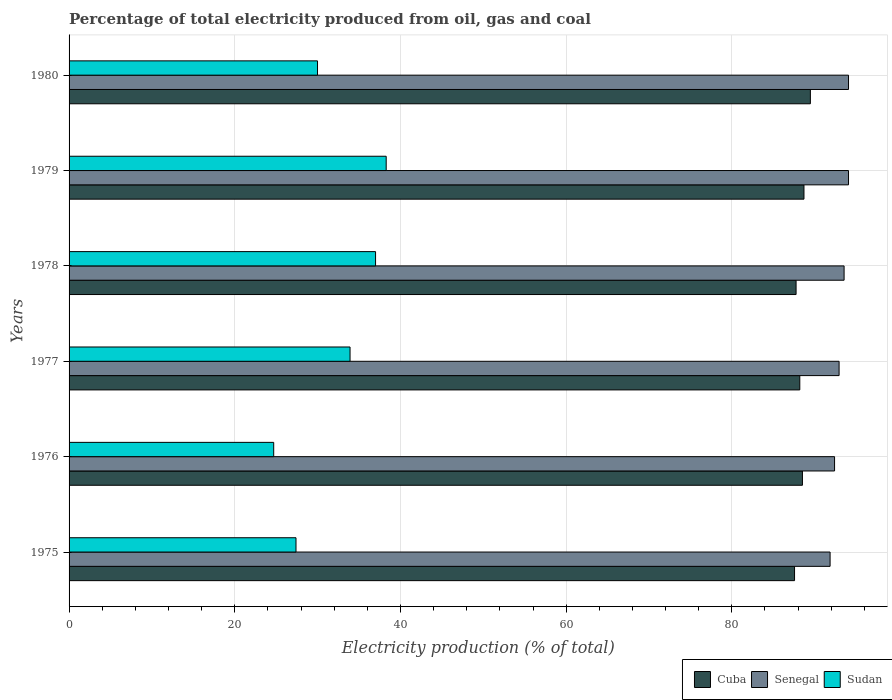How many different coloured bars are there?
Offer a very short reply. 3. Are the number of bars per tick equal to the number of legend labels?
Keep it short and to the point. Yes. How many bars are there on the 1st tick from the top?
Make the answer very short. 3. How many bars are there on the 3rd tick from the bottom?
Give a very brief answer. 3. What is the label of the 4th group of bars from the top?
Provide a short and direct response. 1977. What is the electricity production in in Sudan in 1977?
Offer a terse response. 33.92. Across all years, what is the maximum electricity production in in Senegal?
Keep it short and to the point. 94.08. Across all years, what is the minimum electricity production in in Cuba?
Ensure brevity in your answer.  87.57. In which year was the electricity production in in Cuba maximum?
Make the answer very short. 1980. In which year was the electricity production in in Sudan minimum?
Give a very brief answer. 1976. What is the total electricity production in in Cuba in the graph?
Give a very brief answer. 530.23. What is the difference between the electricity production in in Cuba in 1975 and that in 1980?
Your answer should be very brief. -1.91. What is the difference between the electricity production in in Senegal in 1980 and the electricity production in in Cuba in 1975?
Your answer should be very brief. 6.51. What is the average electricity production in in Cuba per year?
Ensure brevity in your answer.  88.37. In the year 1976, what is the difference between the electricity production in in Cuba and electricity production in in Senegal?
Your answer should be compact. -3.88. In how many years, is the electricity production in in Senegal greater than 8 %?
Your answer should be very brief. 6. What is the ratio of the electricity production in in Senegal in 1976 to that in 1979?
Offer a terse response. 0.98. Is the difference between the electricity production in in Cuba in 1976 and 1979 greater than the difference between the electricity production in in Senegal in 1976 and 1979?
Offer a very short reply. Yes. What is the difference between the highest and the second highest electricity production in in Sudan?
Your answer should be very brief. 1.28. What is the difference between the highest and the lowest electricity production in in Sudan?
Offer a terse response. 13.58. In how many years, is the electricity production in in Senegal greater than the average electricity production in in Senegal taken over all years?
Your answer should be very brief. 3. Is the sum of the electricity production in in Senegal in 1978 and 1979 greater than the maximum electricity production in in Cuba across all years?
Your response must be concise. Yes. What does the 2nd bar from the top in 1980 represents?
Your answer should be compact. Senegal. What does the 1st bar from the bottom in 1980 represents?
Provide a succinct answer. Cuba. Is it the case that in every year, the sum of the electricity production in in Cuba and electricity production in in Senegal is greater than the electricity production in in Sudan?
Your answer should be compact. Yes. How many bars are there?
Your answer should be very brief. 18. How many years are there in the graph?
Give a very brief answer. 6. What is the difference between two consecutive major ticks on the X-axis?
Offer a very short reply. 20. Are the values on the major ticks of X-axis written in scientific E-notation?
Your answer should be very brief. No. Does the graph contain any zero values?
Offer a terse response. No. How many legend labels are there?
Your answer should be compact. 3. How are the legend labels stacked?
Your answer should be compact. Horizontal. What is the title of the graph?
Provide a short and direct response. Percentage of total electricity produced from oil, gas and coal. Does "Qatar" appear as one of the legend labels in the graph?
Ensure brevity in your answer.  No. What is the label or title of the X-axis?
Your answer should be compact. Electricity production (% of total). What is the label or title of the Y-axis?
Your answer should be compact. Years. What is the Electricity production (% of total) of Cuba in 1975?
Provide a succinct answer. 87.57. What is the Electricity production (% of total) of Senegal in 1975?
Offer a very short reply. 91.86. What is the Electricity production (% of total) in Sudan in 1975?
Your answer should be compact. 27.39. What is the Electricity production (% of total) of Cuba in 1976?
Provide a succinct answer. 88.52. What is the Electricity production (% of total) of Senegal in 1976?
Keep it short and to the point. 92.4. What is the Electricity production (% of total) of Sudan in 1976?
Your response must be concise. 24.7. What is the Electricity production (% of total) in Cuba in 1977?
Offer a terse response. 88.2. What is the Electricity production (% of total) in Senegal in 1977?
Give a very brief answer. 92.95. What is the Electricity production (% of total) in Sudan in 1977?
Keep it short and to the point. 33.92. What is the Electricity production (% of total) in Cuba in 1978?
Offer a very short reply. 87.75. What is the Electricity production (% of total) of Senegal in 1978?
Give a very brief answer. 93.55. What is the Electricity production (% of total) in Sudan in 1978?
Provide a succinct answer. 36.99. What is the Electricity production (% of total) in Cuba in 1979?
Give a very brief answer. 88.7. What is the Electricity production (% of total) in Senegal in 1979?
Make the answer very short. 94.08. What is the Electricity production (% of total) in Sudan in 1979?
Provide a short and direct response. 38.28. What is the Electricity production (% of total) in Cuba in 1980?
Keep it short and to the point. 89.48. What is the Electricity production (% of total) in Senegal in 1980?
Give a very brief answer. 94.08. What is the Electricity production (% of total) of Sudan in 1980?
Your response must be concise. 29.99. Across all years, what is the maximum Electricity production (% of total) in Cuba?
Give a very brief answer. 89.48. Across all years, what is the maximum Electricity production (% of total) of Senegal?
Ensure brevity in your answer.  94.08. Across all years, what is the maximum Electricity production (% of total) in Sudan?
Provide a succinct answer. 38.28. Across all years, what is the minimum Electricity production (% of total) in Cuba?
Your answer should be compact. 87.57. Across all years, what is the minimum Electricity production (% of total) in Senegal?
Your answer should be compact. 91.86. Across all years, what is the minimum Electricity production (% of total) of Sudan?
Provide a succinct answer. 24.7. What is the total Electricity production (% of total) of Cuba in the graph?
Ensure brevity in your answer.  530.23. What is the total Electricity production (% of total) in Senegal in the graph?
Ensure brevity in your answer.  558.92. What is the total Electricity production (% of total) of Sudan in the graph?
Provide a short and direct response. 191.27. What is the difference between the Electricity production (% of total) in Cuba in 1975 and that in 1976?
Your response must be concise. -0.95. What is the difference between the Electricity production (% of total) of Senegal in 1975 and that in 1976?
Your answer should be very brief. -0.54. What is the difference between the Electricity production (% of total) of Sudan in 1975 and that in 1976?
Keep it short and to the point. 2.69. What is the difference between the Electricity production (% of total) in Cuba in 1975 and that in 1977?
Your response must be concise. -0.63. What is the difference between the Electricity production (% of total) in Senegal in 1975 and that in 1977?
Provide a short and direct response. -1.09. What is the difference between the Electricity production (% of total) of Sudan in 1975 and that in 1977?
Keep it short and to the point. -6.52. What is the difference between the Electricity production (% of total) in Cuba in 1975 and that in 1978?
Offer a very short reply. -0.19. What is the difference between the Electricity production (% of total) of Senegal in 1975 and that in 1978?
Offer a very short reply. -1.69. What is the difference between the Electricity production (% of total) of Sudan in 1975 and that in 1978?
Offer a very short reply. -9.6. What is the difference between the Electricity production (% of total) in Cuba in 1975 and that in 1979?
Offer a very short reply. -1.14. What is the difference between the Electricity production (% of total) in Senegal in 1975 and that in 1979?
Provide a succinct answer. -2.22. What is the difference between the Electricity production (% of total) of Sudan in 1975 and that in 1979?
Offer a very short reply. -10.89. What is the difference between the Electricity production (% of total) of Cuba in 1975 and that in 1980?
Your answer should be very brief. -1.91. What is the difference between the Electricity production (% of total) in Senegal in 1975 and that in 1980?
Your response must be concise. -2.22. What is the difference between the Electricity production (% of total) in Sudan in 1975 and that in 1980?
Make the answer very short. -2.6. What is the difference between the Electricity production (% of total) of Cuba in 1976 and that in 1977?
Your response must be concise. 0.32. What is the difference between the Electricity production (% of total) in Senegal in 1976 and that in 1977?
Give a very brief answer. -0.55. What is the difference between the Electricity production (% of total) of Sudan in 1976 and that in 1977?
Offer a terse response. -9.22. What is the difference between the Electricity production (% of total) of Cuba in 1976 and that in 1978?
Your response must be concise. 0.77. What is the difference between the Electricity production (% of total) of Senegal in 1976 and that in 1978?
Offer a very short reply. -1.15. What is the difference between the Electricity production (% of total) of Sudan in 1976 and that in 1978?
Offer a very short reply. -12.29. What is the difference between the Electricity production (% of total) of Cuba in 1976 and that in 1979?
Your answer should be very brief. -0.18. What is the difference between the Electricity production (% of total) of Senegal in 1976 and that in 1979?
Provide a short and direct response. -1.69. What is the difference between the Electricity production (% of total) of Sudan in 1976 and that in 1979?
Offer a terse response. -13.58. What is the difference between the Electricity production (% of total) in Cuba in 1976 and that in 1980?
Keep it short and to the point. -0.96. What is the difference between the Electricity production (% of total) of Senegal in 1976 and that in 1980?
Provide a succinct answer. -1.69. What is the difference between the Electricity production (% of total) of Sudan in 1976 and that in 1980?
Offer a very short reply. -5.29. What is the difference between the Electricity production (% of total) of Cuba in 1977 and that in 1978?
Ensure brevity in your answer.  0.45. What is the difference between the Electricity production (% of total) in Senegal in 1977 and that in 1978?
Ensure brevity in your answer.  -0.6. What is the difference between the Electricity production (% of total) of Sudan in 1977 and that in 1978?
Provide a succinct answer. -3.08. What is the difference between the Electricity production (% of total) in Cuba in 1977 and that in 1979?
Your answer should be very brief. -0.5. What is the difference between the Electricity production (% of total) in Senegal in 1977 and that in 1979?
Keep it short and to the point. -1.14. What is the difference between the Electricity production (% of total) of Sudan in 1977 and that in 1979?
Ensure brevity in your answer.  -4.36. What is the difference between the Electricity production (% of total) of Cuba in 1977 and that in 1980?
Provide a short and direct response. -1.28. What is the difference between the Electricity production (% of total) in Senegal in 1977 and that in 1980?
Your answer should be compact. -1.14. What is the difference between the Electricity production (% of total) in Sudan in 1977 and that in 1980?
Your answer should be compact. 3.93. What is the difference between the Electricity production (% of total) in Cuba in 1978 and that in 1979?
Make the answer very short. -0.95. What is the difference between the Electricity production (% of total) in Senegal in 1978 and that in 1979?
Your answer should be compact. -0.53. What is the difference between the Electricity production (% of total) in Sudan in 1978 and that in 1979?
Give a very brief answer. -1.28. What is the difference between the Electricity production (% of total) of Cuba in 1978 and that in 1980?
Offer a terse response. -1.73. What is the difference between the Electricity production (% of total) in Senegal in 1978 and that in 1980?
Your response must be concise. -0.53. What is the difference between the Electricity production (% of total) in Sudan in 1978 and that in 1980?
Provide a short and direct response. 7.01. What is the difference between the Electricity production (% of total) in Cuba in 1979 and that in 1980?
Make the answer very short. -0.77. What is the difference between the Electricity production (% of total) in Senegal in 1979 and that in 1980?
Keep it short and to the point. 0. What is the difference between the Electricity production (% of total) of Sudan in 1979 and that in 1980?
Ensure brevity in your answer.  8.29. What is the difference between the Electricity production (% of total) of Cuba in 1975 and the Electricity production (% of total) of Senegal in 1976?
Offer a very short reply. -4.83. What is the difference between the Electricity production (% of total) of Cuba in 1975 and the Electricity production (% of total) of Sudan in 1976?
Provide a succinct answer. 62.87. What is the difference between the Electricity production (% of total) in Senegal in 1975 and the Electricity production (% of total) in Sudan in 1976?
Ensure brevity in your answer.  67.16. What is the difference between the Electricity production (% of total) in Cuba in 1975 and the Electricity production (% of total) in Senegal in 1977?
Provide a succinct answer. -5.38. What is the difference between the Electricity production (% of total) of Cuba in 1975 and the Electricity production (% of total) of Sudan in 1977?
Keep it short and to the point. 53.65. What is the difference between the Electricity production (% of total) in Senegal in 1975 and the Electricity production (% of total) in Sudan in 1977?
Give a very brief answer. 57.94. What is the difference between the Electricity production (% of total) in Cuba in 1975 and the Electricity production (% of total) in Senegal in 1978?
Provide a succinct answer. -5.98. What is the difference between the Electricity production (% of total) in Cuba in 1975 and the Electricity production (% of total) in Sudan in 1978?
Make the answer very short. 50.57. What is the difference between the Electricity production (% of total) in Senegal in 1975 and the Electricity production (% of total) in Sudan in 1978?
Offer a very short reply. 54.86. What is the difference between the Electricity production (% of total) in Cuba in 1975 and the Electricity production (% of total) in Senegal in 1979?
Provide a short and direct response. -6.51. What is the difference between the Electricity production (% of total) of Cuba in 1975 and the Electricity production (% of total) of Sudan in 1979?
Make the answer very short. 49.29. What is the difference between the Electricity production (% of total) in Senegal in 1975 and the Electricity production (% of total) in Sudan in 1979?
Ensure brevity in your answer.  53.58. What is the difference between the Electricity production (% of total) in Cuba in 1975 and the Electricity production (% of total) in Senegal in 1980?
Ensure brevity in your answer.  -6.51. What is the difference between the Electricity production (% of total) in Cuba in 1975 and the Electricity production (% of total) in Sudan in 1980?
Offer a very short reply. 57.58. What is the difference between the Electricity production (% of total) of Senegal in 1975 and the Electricity production (% of total) of Sudan in 1980?
Make the answer very short. 61.87. What is the difference between the Electricity production (% of total) in Cuba in 1976 and the Electricity production (% of total) in Senegal in 1977?
Ensure brevity in your answer.  -4.43. What is the difference between the Electricity production (% of total) in Cuba in 1976 and the Electricity production (% of total) in Sudan in 1977?
Ensure brevity in your answer.  54.6. What is the difference between the Electricity production (% of total) of Senegal in 1976 and the Electricity production (% of total) of Sudan in 1977?
Provide a succinct answer. 58.48. What is the difference between the Electricity production (% of total) of Cuba in 1976 and the Electricity production (% of total) of Senegal in 1978?
Offer a very short reply. -5.03. What is the difference between the Electricity production (% of total) in Cuba in 1976 and the Electricity production (% of total) in Sudan in 1978?
Ensure brevity in your answer.  51.53. What is the difference between the Electricity production (% of total) of Senegal in 1976 and the Electricity production (% of total) of Sudan in 1978?
Offer a terse response. 55.4. What is the difference between the Electricity production (% of total) in Cuba in 1976 and the Electricity production (% of total) in Senegal in 1979?
Your answer should be very brief. -5.56. What is the difference between the Electricity production (% of total) in Cuba in 1976 and the Electricity production (% of total) in Sudan in 1979?
Make the answer very short. 50.24. What is the difference between the Electricity production (% of total) in Senegal in 1976 and the Electricity production (% of total) in Sudan in 1979?
Ensure brevity in your answer.  54.12. What is the difference between the Electricity production (% of total) of Cuba in 1976 and the Electricity production (% of total) of Senegal in 1980?
Provide a succinct answer. -5.56. What is the difference between the Electricity production (% of total) of Cuba in 1976 and the Electricity production (% of total) of Sudan in 1980?
Your answer should be very brief. 58.53. What is the difference between the Electricity production (% of total) of Senegal in 1976 and the Electricity production (% of total) of Sudan in 1980?
Give a very brief answer. 62.41. What is the difference between the Electricity production (% of total) in Cuba in 1977 and the Electricity production (% of total) in Senegal in 1978?
Make the answer very short. -5.35. What is the difference between the Electricity production (% of total) in Cuba in 1977 and the Electricity production (% of total) in Sudan in 1978?
Ensure brevity in your answer.  51.21. What is the difference between the Electricity production (% of total) in Senegal in 1977 and the Electricity production (% of total) in Sudan in 1978?
Your response must be concise. 55.95. What is the difference between the Electricity production (% of total) in Cuba in 1977 and the Electricity production (% of total) in Senegal in 1979?
Keep it short and to the point. -5.88. What is the difference between the Electricity production (% of total) in Cuba in 1977 and the Electricity production (% of total) in Sudan in 1979?
Ensure brevity in your answer.  49.92. What is the difference between the Electricity production (% of total) in Senegal in 1977 and the Electricity production (% of total) in Sudan in 1979?
Give a very brief answer. 54.67. What is the difference between the Electricity production (% of total) in Cuba in 1977 and the Electricity production (% of total) in Senegal in 1980?
Your answer should be compact. -5.88. What is the difference between the Electricity production (% of total) in Cuba in 1977 and the Electricity production (% of total) in Sudan in 1980?
Give a very brief answer. 58.21. What is the difference between the Electricity production (% of total) of Senegal in 1977 and the Electricity production (% of total) of Sudan in 1980?
Provide a short and direct response. 62.96. What is the difference between the Electricity production (% of total) in Cuba in 1978 and the Electricity production (% of total) in Senegal in 1979?
Your response must be concise. -6.33. What is the difference between the Electricity production (% of total) in Cuba in 1978 and the Electricity production (% of total) in Sudan in 1979?
Provide a succinct answer. 49.48. What is the difference between the Electricity production (% of total) in Senegal in 1978 and the Electricity production (% of total) in Sudan in 1979?
Provide a short and direct response. 55.27. What is the difference between the Electricity production (% of total) of Cuba in 1978 and the Electricity production (% of total) of Senegal in 1980?
Provide a short and direct response. -6.33. What is the difference between the Electricity production (% of total) of Cuba in 1978 and the Electricity production (% of total) of Sudan in 1980?
Provide a succinct answer. 57.77. What is the difference between the Electricity production (% of total) of Senegal in 1978 and the Electricity production (% of total) of Sudan in 1980?
Your response must be concise. 63.56. What is the difference between the Electricity production (% of total) of Cuba in 1979 and the Electricity production (% of total) of Senegal in 1980?
Give a very brief answer. -5.38. What is the difference between the Electricity production (% of total) in Cuba in 1979 and the Electricity production (% of total) in Sudan in 1980?
Your response must be concise. 58.72. What is the difference between the Electricity production (% of total) in Senegal in 1979 and the Electricity production (% of total) in Sudan in 1980?
Your response must be concise. 64.1. What is the average Electricity production (% of total) of Cuba per year?
Keep it short and to the point. 88.37. What is the average Electricity production (% of total) of Senegal per year?
Keep it short and to the point. 93.15. What is the average Electricity production (% of total) of Sudan per year?
Provide a short and direct response. 31.88. In the year 1975, what is the difference between the Electricity production (% of total) in Cuba and Electricity production (% of total) in Senegal?
Give a very brief answer. -4.29. In the year 1975, what is the difference between the Electricity production (% of total) of Cuba and Electricity production (% of total) of Sudan?
Your response must be concise. 60.18. In the year 1975, what is the difference between the Electricity production (% of total) in Senegal and Electricity production (% of total) in Sudan?
Offer a terse response. 64.47. In the year 1976, what is the difference between the Electricity production (% of total) of Cuba and Electricity production (% of total) of Senegal?
Provide a succinct answer. -3.88. In the year 1976, what is the difference between the Electricity production (% of total) of Cuba and Electricity production (% of total) of Sudan?
Keep it short and to the point. 63.82. In the year 1976, what is the difference between the Electricity production (% of total) of Senegal and Electricity production (% of total) of Sudan?
Provide a succinct answer. 67.7. In the year 1977, what is the difference between the Electricity production (% of total) in Cuba and Electricity production (% of total) in Senegal?
Offer a terse response. -4.74. In the year 1977, what is the difference between the Electricity production (% of total) of Cuba and Electricity production (% of total) of Sudan?
Make the answer very short. 54.29. In the year 1977, what is the difference between the Electricity production (% of total) in Senegal and Electricity production (% of total) in Sudan?
Your answer should be very brief. 59.03. In the year 1978, what is the difference between the Electricity production (% of total) of Cuba and Electricity production (% of total) of Senegal?
Your response must be concise. -5.79. In the year 1978, what is the difference between the Electricity production (% of total) of Cuba and Electricity production (% of total) of Sudan?
Provide a succinct answer. 50.76. In the year 1978, what is the difference between the Electricity production (% of total) of Senegal and Electricity production (% of total) of Sudan?
Make the answer very short. 56.55. In the year 1979, what is the difference between the Electricity production (% of total) of Cuba and Electricity production (% of total) of Senegal?
Offer a terse response. -5.38. In the year 1979, what is the difference between the Electricity production (% of total) of Cuba and Electricity production (% of total) of Sudan?
Your response must be concise. 50.43. In the year 1979, what is the difference between the Electricity production (% of total) of Senegal and Electricity production (% of total) of Sudan?
Your response must be concise. 55.8. In the year 1980, what is the difference between the Electricity production (% of total) in Cuba and Electricity production (% of total) in Senegal?
Offer a very short reply. -4.6. In the year 1980, what is the difference between the Electricity production (% of total) in Cuba and Electricity production (% of total) in Sudan?
Your answer should be compact. 59.49. In the year 1980, what is the difference between the Electricity production (% of total) of Senegal and Electricity production (% of total) of Sudan?
Keep it short and to the point. 64.1. What is the ratio of the Electricity production (% of total) in Cuba in 1975 to that in 1976?
Give a very brief answer. 0.99. What is the ratio of the Electricity production (% of total) in Senegal in 1975 to that in 1976?
Offer a very short reply. 0.99. What is the ratio of the Electricity production (% of total) of Sudan in 1975 to that in 1976?
Give a very brief answer. 1.11. What is the ratio of the Electricity production (% of total) in Cuba in 1975 to that in 1977?
Your response must be concise. 0.99. What is the ratio of the Electricity production (% of total) of Senegal in 1975 to that in 1977?
Make the answer very short. 0.99. What is the ratio of the Electricity production (% of total) in Sudan in 1975 to that in 1977?
Ensure brevity in your answer.  0.81. What is the ratio of the Electricity production (% of total) in Senegal in 1975 to that in 1978?
Keep it short and to the point. 0.98. What is the ratio of the Electricity production (% of total) in Sudan in 1975 to that in 1978?
Offer a terse response. 0.74. What is the ratio of the Electricity production (% of total) in Cuba in 1975 to that in 1979?
Give a very brief answer. 0.99. What is the ratio of the Electricity production (% of total) in Senegal in 1975 to that in 1979?
Keep it short and to the point. 0.98. What is the ratio of the Electricity production (% of total) in Sudan in 1975 to that in 1979?
Offer a very short reply. 0.72. What is the ratio of the Electricity production (% of total) in Cuba in 1975 to that in 1980?
Your answer should be compact. 0.98. What is the ratio of the Electricity production (% of total) of Senegal in 1975 to that in 1980?
Offer a very short reply. 0.98. What is the ratio of the Electricity production (% of total) in Sudan in 1975 to that in 1980?
Your answer should be very brief. 0.91. What is the ratio of the Electricity production (% of total) of Cuba in 1976 to that in 1977?
Keep it short and to the point. 1. What is the ratio of the Electricity production (% of total) in Senegal in 1976 to that in 1977?
Give a very brief answer. 0.99. What is the ratio of the Electricity production (% of total) in Sudan in 1976 to that in 1977?
Your answer should be very brief. 0.73. What is the ratio of the Electricity production (% of total) of Cuba in 1976 to that in 1978?
Keep it short and to the point. 1.01. What is the ratio of the Electricity production (% of total) of Sudan in 1976 to that in 1978?
Offer a very short reply. 0.67. What is the ratio of the Electricity production (% of total) of Cuba in 1976 to that in 1979?
Offer a terse response. 1. What is the ratio of the Electricity production (% of total) in Senegal in 1976 to that in 1979?
Your answer should be very brief. 0.98. What is the ratio of the Electricity production (% of total) of Sudan in 1976 to that in 1979?
Your answer should be compact. 0.65. What is the ratio of the Electricity production (% of total) in Cuba in 1976 to that in 1980?
Your response must be concise. 0.99. What is the ratio of the Electricity production (% of total) in Senegal in 1976 to that in 1980?
Your answer should be very brief. 0.98. What is the ratio of the Electricity production (% of total) in Sudan in 1976 to that in 1980?
Provide a succinct answer. 0.82. What is the ratio of the Electricity production (% of total) of Cuba in 1977 to that in 1978?
Make the answer very short. 1.01. What is the ratio of the Electricity production (% of total) in Sudan in 1977 to that in 1978?
Your answer should be compact. 0.92. What is the ratio of the Electricity production (% of total) in Senegal in 1977 to that in 1979?
Provide a succinct answer. 0.99. What is the ratio of the Electricity production (% of total) of Sudan in 1977 to that in 1979?
Give a very brief answer. 0.89. What is the ratio of the Electricity production (% of total) in Cuba in 1977 to that in 1980?
Provide a succinct answer. 0.99. What is the ratio of the Electricity production (% of total) in Senegal in 1977 to that in 1980?
Your answer should be compact. 0.99. What is the ratio of the Electricity production (% of total) in Sudan in 1977 to that in 1980?
Offer a very short reply. 1.13. What is the ratio of the Electricity production (% of total) in Cuba in 1978 to that in 1979?
Provide a succinct answer. 0.99. What is the ratio of the Electricity production (% of total) in Sudan in 1978 to that in 1979?
Make the answer very short. 0.97. What is the ratio of the Electricity production (% of total) in Cuba in 1978 to that in 1980?
Your answer should be compact. 0.98. What is the ratio of the Electricity production (% of total) of Sudan in 1978 to that in 1980?
Ensure brevity in your answer.  1.23. What is the ratio of the Electricity production (% of total) in Cuba in 1979 to that in 1980?
Give a very brief answer. 0.99. What is the ratio of the Electricity production (% of total) in Sudan in 1979 to that in 1980?
Ensure brevity in your answer.  1.28. What is the difference between the highest and the second highest Electricity production (% of total) of Cuba?
Offer a very short reply. 0.77. What is the difference between the highest and the second highest Electricity production (% of total) in Senegal?
Provide a short and direct response. 0. What is the difference between the highest and the second highest Electricity production (% of total) of Sudan?
Make the answer very short. 1.28. What is the difference between the highest and the lowest Electricity production (% of total) in Cuba?
Make the answer very short. 1.91. What is the difference between the highest and the lowest Electricity production (% of total) in Senegal?
Your response must be concise. 2.22. What is the difference between the highest and the lowest Electricity production (% of total) in Sudan?
Provide a succinct answer. 13.58. 